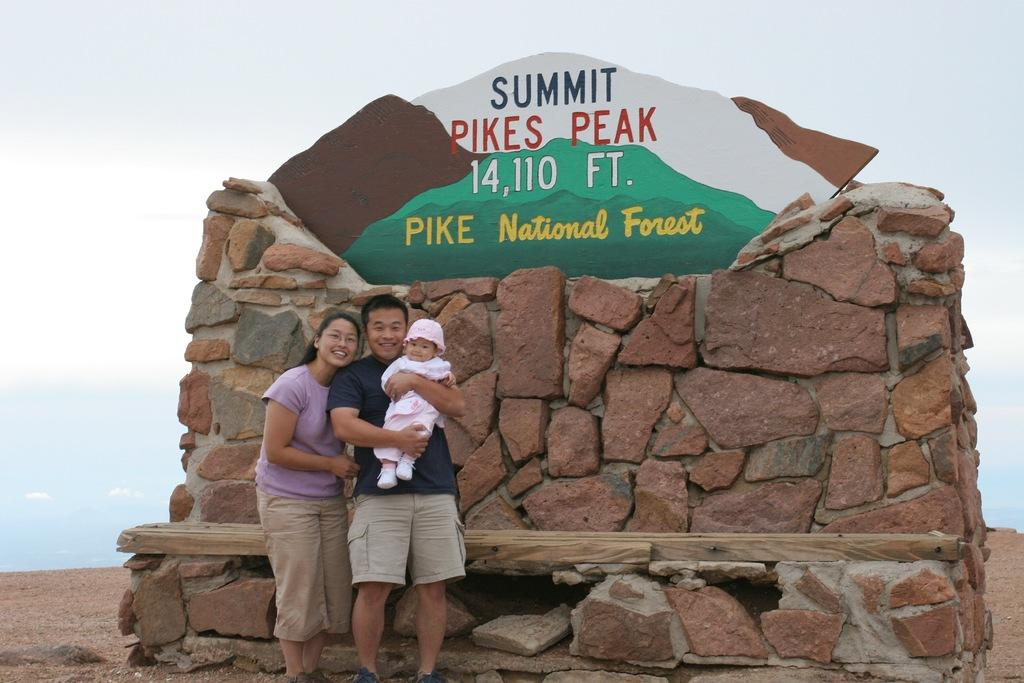How many people are present in the image? There are two persons standing in the image. What is the third person in the image doing? There is a person holding a baby in the image. What can be seen in the background of the image? There is a name board on rocks and water visible in the background of the image. What else is visible in the background of the image? The sky is visible in the background of the image. What type of art can be seen on the rocks in the image? There is no art visible on the rocks in the image; there is only a name board. What flavor of pickle is being held by the person holding the baby? There is no pickle present in the image; the person is holding a baby. 